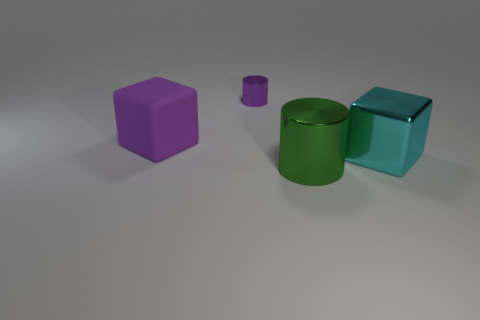Add 4 purple objects. How many objects exist? 8 Subtract 0 gray cubes. How many objects are left? 4 Subtract all green objects. Subtract all small metal things. How many objects are left? 2 Add 1 small purple metal things. How many small purple metal things are left? 2 Add 4 purple metal cylinders. How many purple metal cylinders exist? 5 